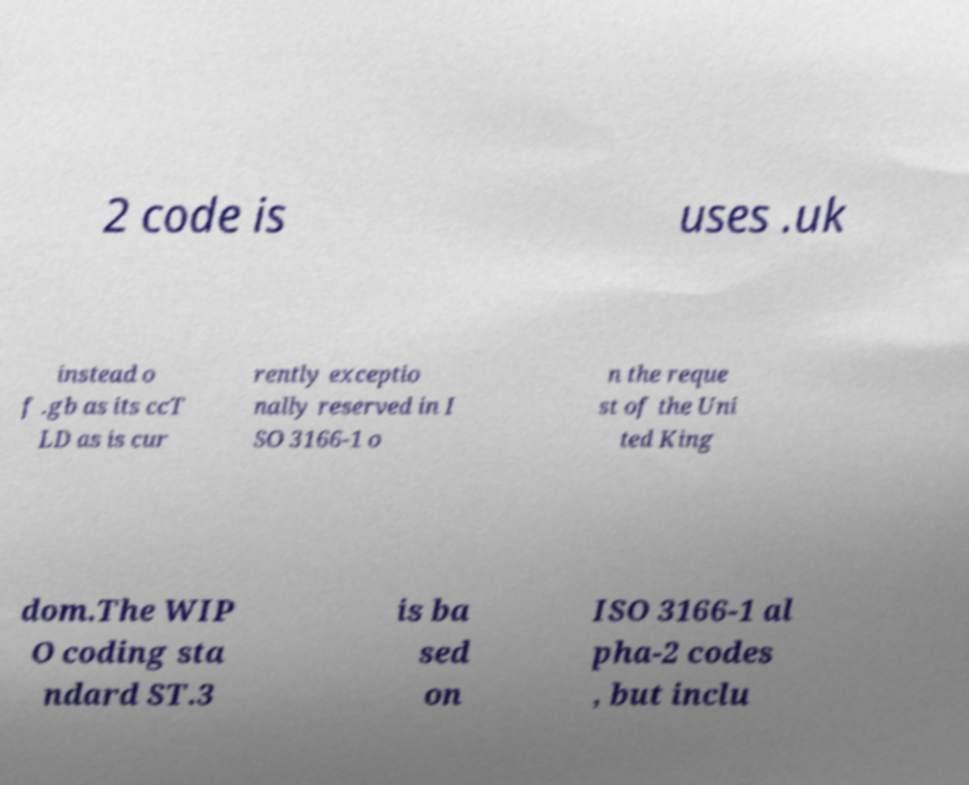Could you extract and type out the text from this image? 2 code is uses .uk instead o f .gb as its ccT LD as is cur rently exceptio nally reserved in I SO 3166-1 o n the reque st of the Uni ted King dom.The WIP O coding sta ndard ST.3 is ba sed on ISO 3166-1 al pha-2 codes , but inclu 